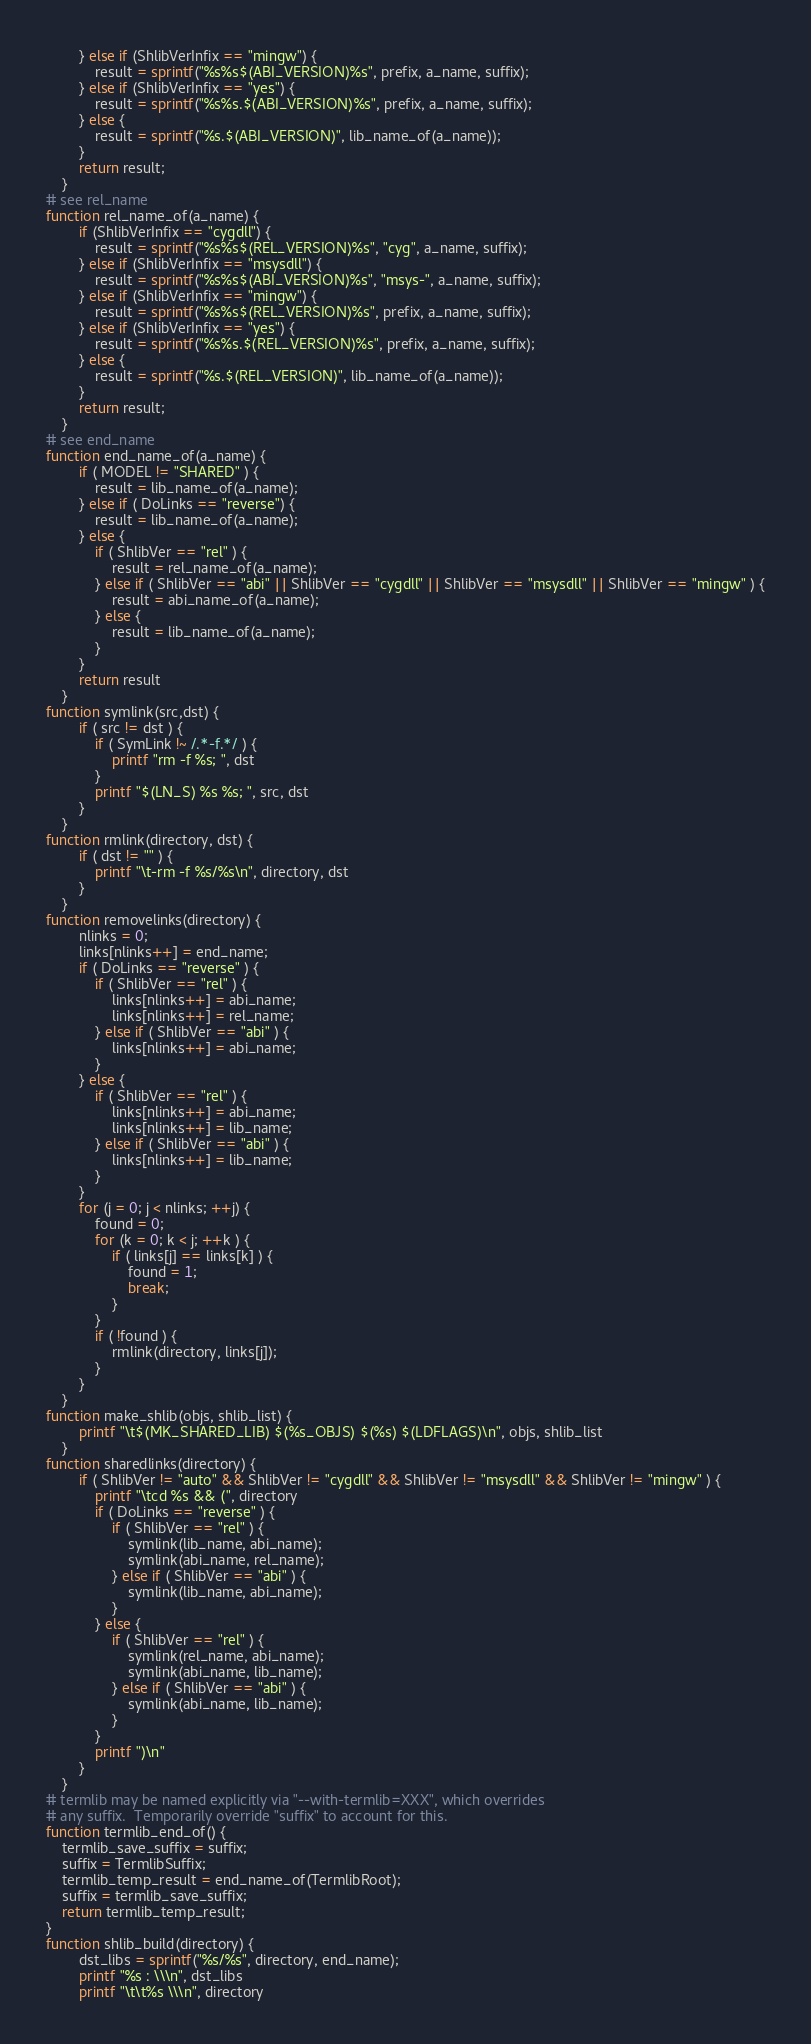<code> <loc_0><loc_0><loc_500><loc_500><_Awk_>		} else if (ShlibVerInfix == "mingw") {
			result = sprintf("%s%s$(ABI_VERSION)%s", prefix, a_name, suffix);
		} else if (ShlibVerInfix == "yes") {
			result = sprintf("%s%s.$(ABI_VERSION)%s", prefix, a_name, suffix);
		} else {
			result = sprintf("%s.$(ABI_VERSION)", lib_name_of(a_name));
		}
		return result;
	}
# see rel_name
function rel_name_of(a_name) {
		if (ShlibVerInfix == "cygdll") {
			result = sprintf("%s%s$(REL_VERSION)%s", "cyg", a_name, suffix);
		} else if (ShlibVerInfix == "msysdll") {
			result = sprintf("%s%s$(ABI_VERSION)%s", "msys-", a_name, suffix);
		} else if (ShlibVerInfix == "mingw") {
			result = sprintf("%s%s$(REL_VERSION)%s", prefix, a_name, suffix);
		} else if (ShlibVerInfix == "yes") {
			result = sprintf("%s%s.$(REL_VERSION)%s", prefix, a_name, suffix);
		} else {
			result = sprintf("%s.$(REL_VERSION)", lib_name_of(a_name));
		}
		return result;
	}
# see end_name
function end_name_of(a_name) {
		if ( MODEL != "SHARED" ) {
			result = lib_name_of(a_name);
		} else if ( DoLinks == "reverse") {
			result = lib_name_of(a_name);
		} else {
			if ( ShlibVer == "rel" ) {
				result = rel_name_of(a_name);
			} else if ( ShlibVer == "abi" || ShlibVer == "cygdll" || ShlibVer == "msysdll" || ShlibVer == "mingw" ) {
				result = abi_name_of(a_name);
			} else {
				result = lib_name_of(a_name);
			}
		}
		return result
	}
function symlink(src,dst) {
		if ( src != dst ) {
			if ( SymLink !~ /.*-f.*/ ) {
				printf "rm -f %s; ", dst
			}
			printf "$(LN_S) %s %s; ", src, dst
		}
	}
function rmlink(directory, dst) {
		if ( dst != "" ) {
			printf "\t-rm -f %s/%s\n", directory, dst
		}
	}
function removelinks(directory) {
		nlinks = 0;
		links[nlinks++] = end_name;
		if ( DoLinks == "reverse" ) {
			if ( ShlibVer == "rel" ) {
				links[nlinks++] = abi_name;
				links[nlinks++] = rel_name;
			} else if ( ShlibVer == "abi" ) {
				links[nlinks++] = abi_name;
			}
		} else {
			if ( ShlibVer == "rel" ) {
				links[nlinks++] = abi_name;
				links[nlinks++] = lib_name;
			} else if ( ShlibVer == "abi" ) {
				links[nlinks++] = lib_name;
			}
		}
		for (j = 0; j < nlinks; ++j) {
			found = 0;
			for (k = 0; k < j; ++k ) {
				if ( links[j] == links[k] ) {
					found = 1;
					break;
				}
			}
			if ( !found ) {
				rmlink(directory, links[j]);
			}
		}
	}
function make_shlib(objs, shlib_list) {
		printf "\t$(MK_SHARED_LIB) $(%s_OBJS) $(%s) $(LDFLAGS)\n", objs, shlib_list
	}
function sharedlinks(directory) {
		if ( ShlibVer != "auto" && ShlibVer != "cygdll" && ShlibVer != "msysdll" && ShlibVer != "mingw" ) {
			printf "\tcd %s && (", directory
			if ( DoLinks == "reverse" ) {
				if ( ShlibVer == "rel" ) {
					symlink(lib_name, abi_name);
					symlink(abi_name, rel_name);
				} else if ( ShlibVer == "abi" ) {
					symlink(lib_name, abi_name);
				}
			} else {
				if ( ShlibVer == "rel" ) {
					symlink(rel_name, abi_name);
					symlink(abi_name, lib_name);
				} else if ( ShlibVer == "abi" ) {
					symlink(abi_name, lib_name);
				}
			}
			printf ")\n"
		}
	}
# termlib may be named explicitly via "--with-termlib=XXX", which overrides
# any suffix.  Temporarily override "suffix" to account for this.
function termlib_end_of() {
	termlib_save_suffix = suffix;
	suffix = TermlibSuffix;
	termlib_temp_result = end_name_of(TermlibRoot);
	suffix = termlib_save_suffix;
	return termlib_temp_result;
}
function shlib_build(directory) {
		dst_libs = sprintf("%s/%s", directory, end_name);
		printf "%s : \\\n", dst_libs
		printf "\t\t%s \\\n", directory</code> 